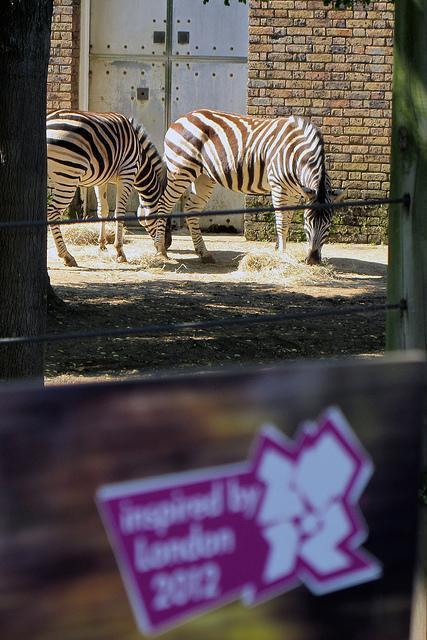How many animals are there?
Give a very brief answer. 2. How many zebras can be seen?
Give a very brief answer. 2. 